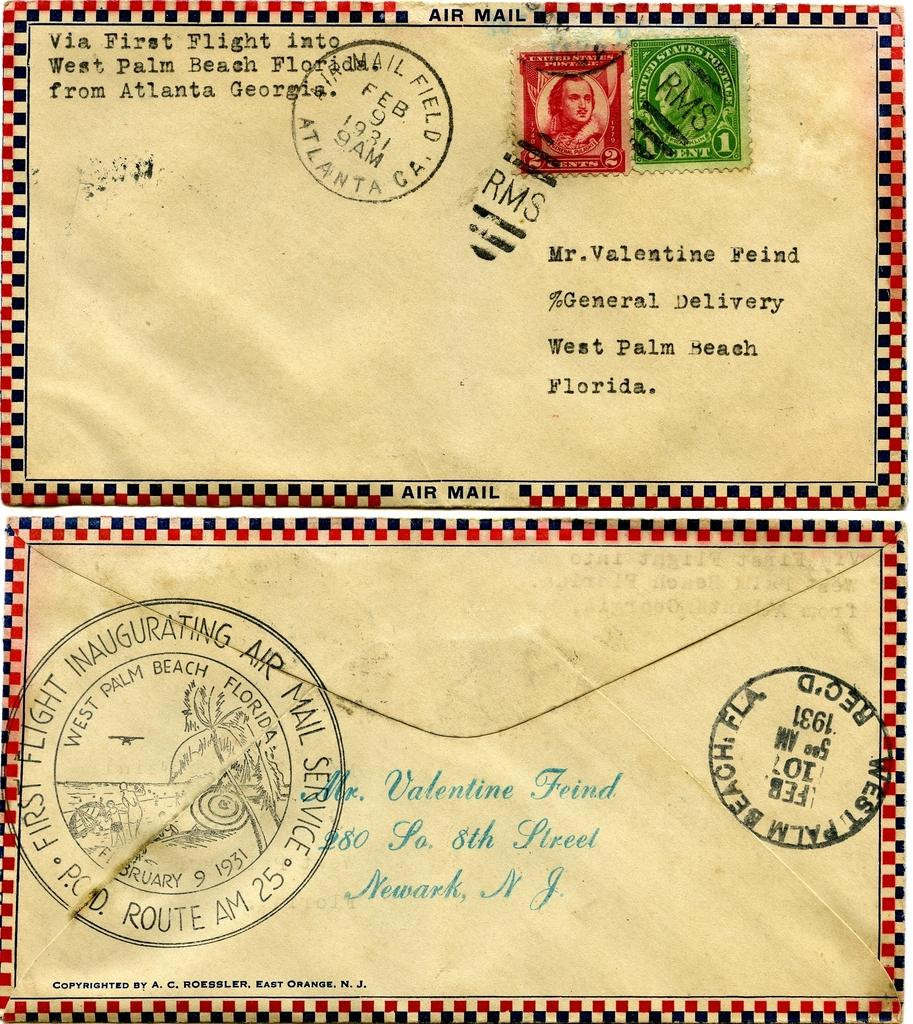<image>
Render a clear and concise summary of the photo. Two letters that are addressed to Mr. Valetine Feind. 